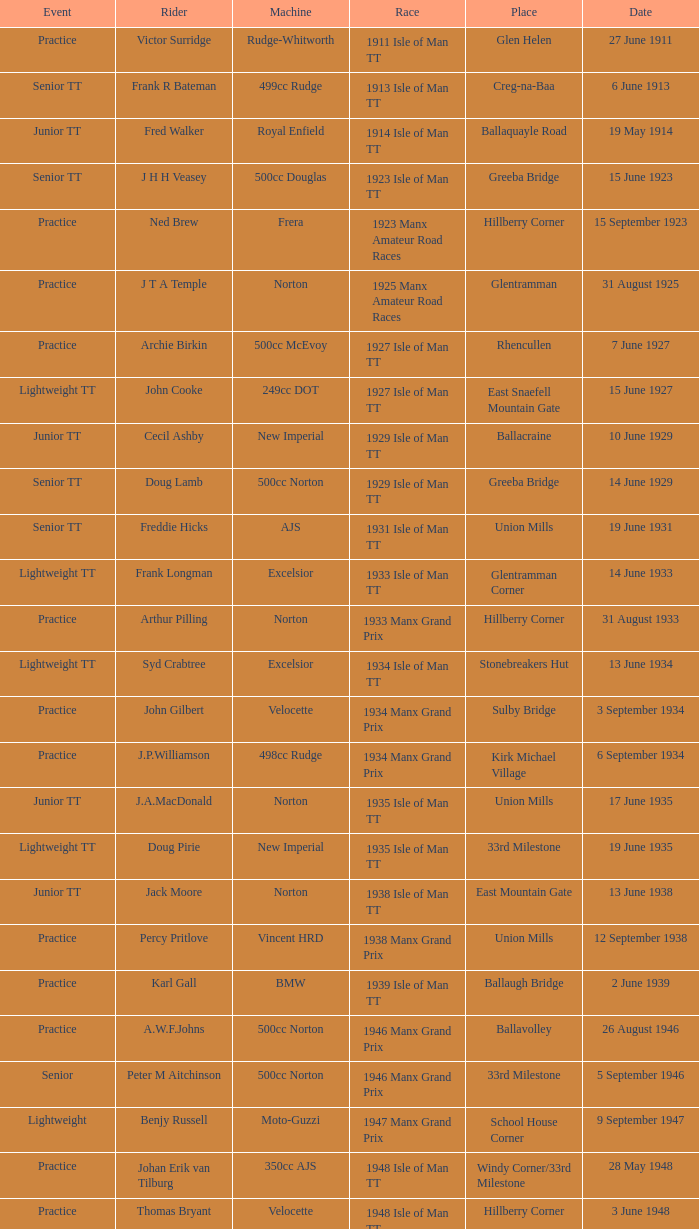Harry l Stephen rides a Norton machine on what date? 8 June 1953. 